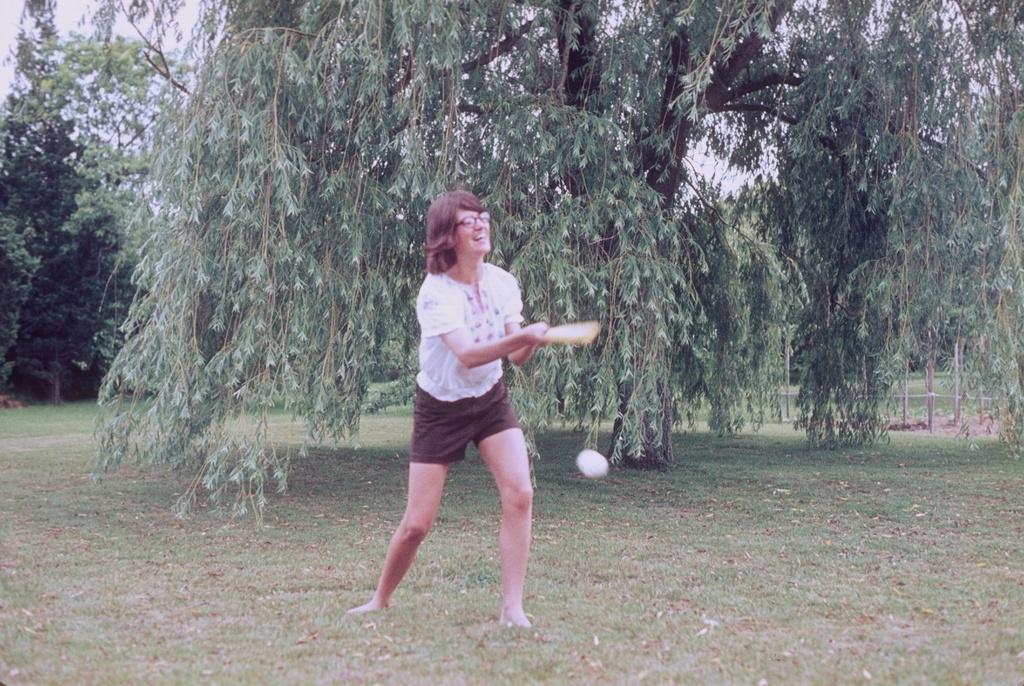Could you give a brief overview of what you see in this image? In this image I can see a woman holding a bat ,standing on the ground and she is smiling ,at the top I can see the sky and tree. 